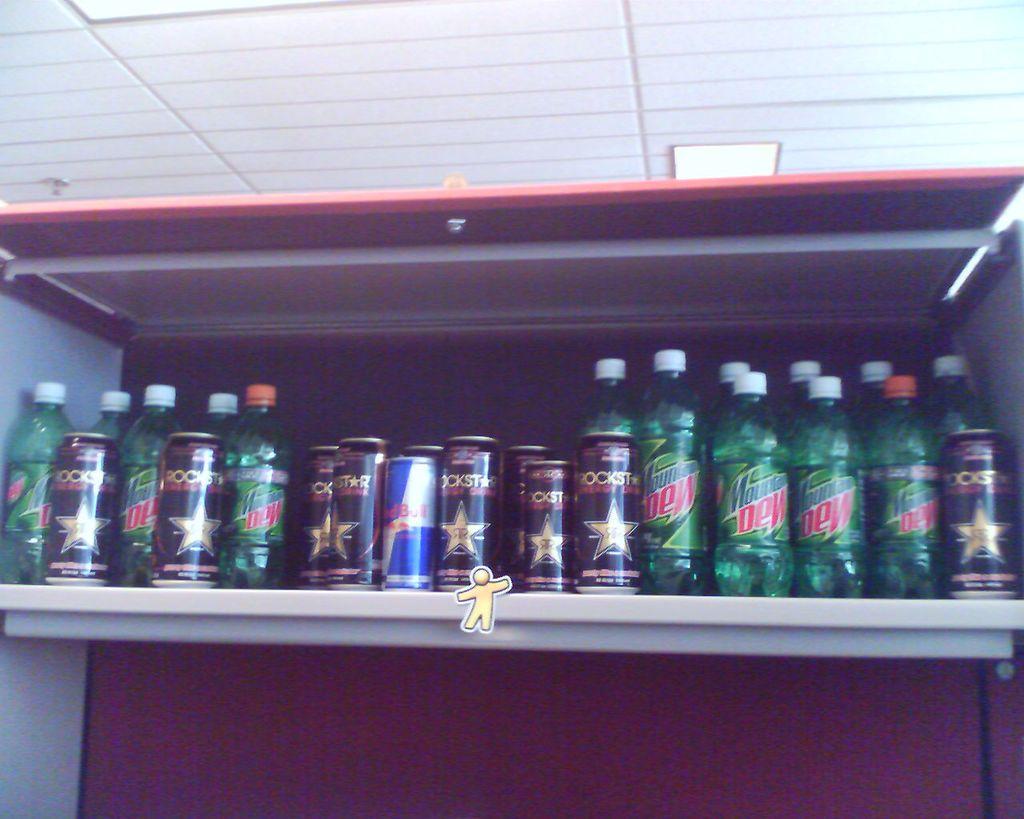What soda is in the green bottles?
Your response must be concise. Mountain dew. 